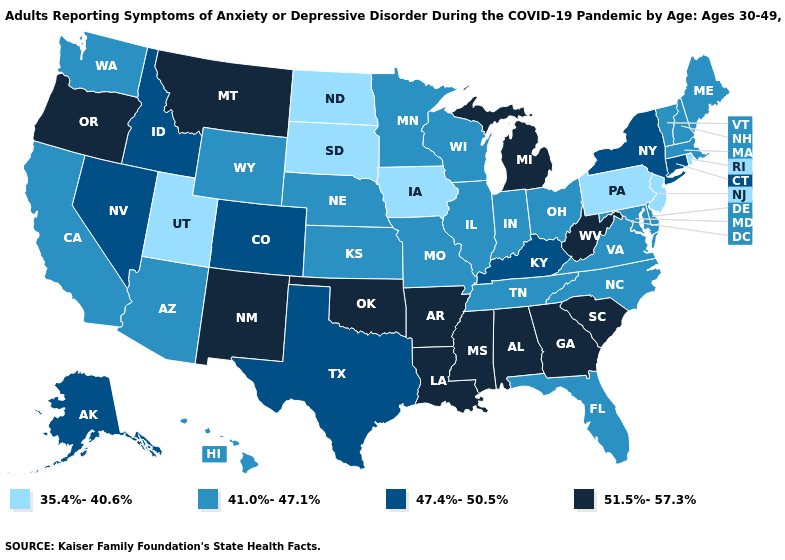Is the legend a continuous bar?
Short answer required. No. What is the value of Connecticut?
Write a very short answer. 47.4%-50.5%. Among the states that border Louisiana , does Texas have the lowest value?
Be succinct. Yes. What is the value of Rhode Island?
Give a very brief answer. 35.4%-40.6%. Which states have the lowest value in the USA?
Give a very brief answer. Iowa, New Jersey, North Dakota, Pennsylvania, Rhode Island, South Dakota, Utah. Is the legend a continuous bar?
Write a very short answer. No. What is the value of California?
Give a very brief answer. 41.0%-47.1%. How many symbols are there in the legend?
Keep it brief. 4. Does Kansas have the lowest value in the USA?
Be succinct. No. What is the value of Maine?
Answer briefly. 41.0%-47.1%. Which states have the highest value in the USA?
Be succinct. Alabama, Arkansas, Georgia, Louisiana, Michigan, Mississippi, Montana, New Mexico, Oklahoma, Oregon, South Carolina, West Virginia. Is the legend a continuous bar?
Give a very brief answer. No. Does South Dakota have the highest value in the USA?
Give a very brief answer. No. What is the lowest value in states that border Massachusetts?
Short answer required. 35.4%-40.6%. What is the value of Maryland?
Answer briefly. 41.0%-47.1%. 